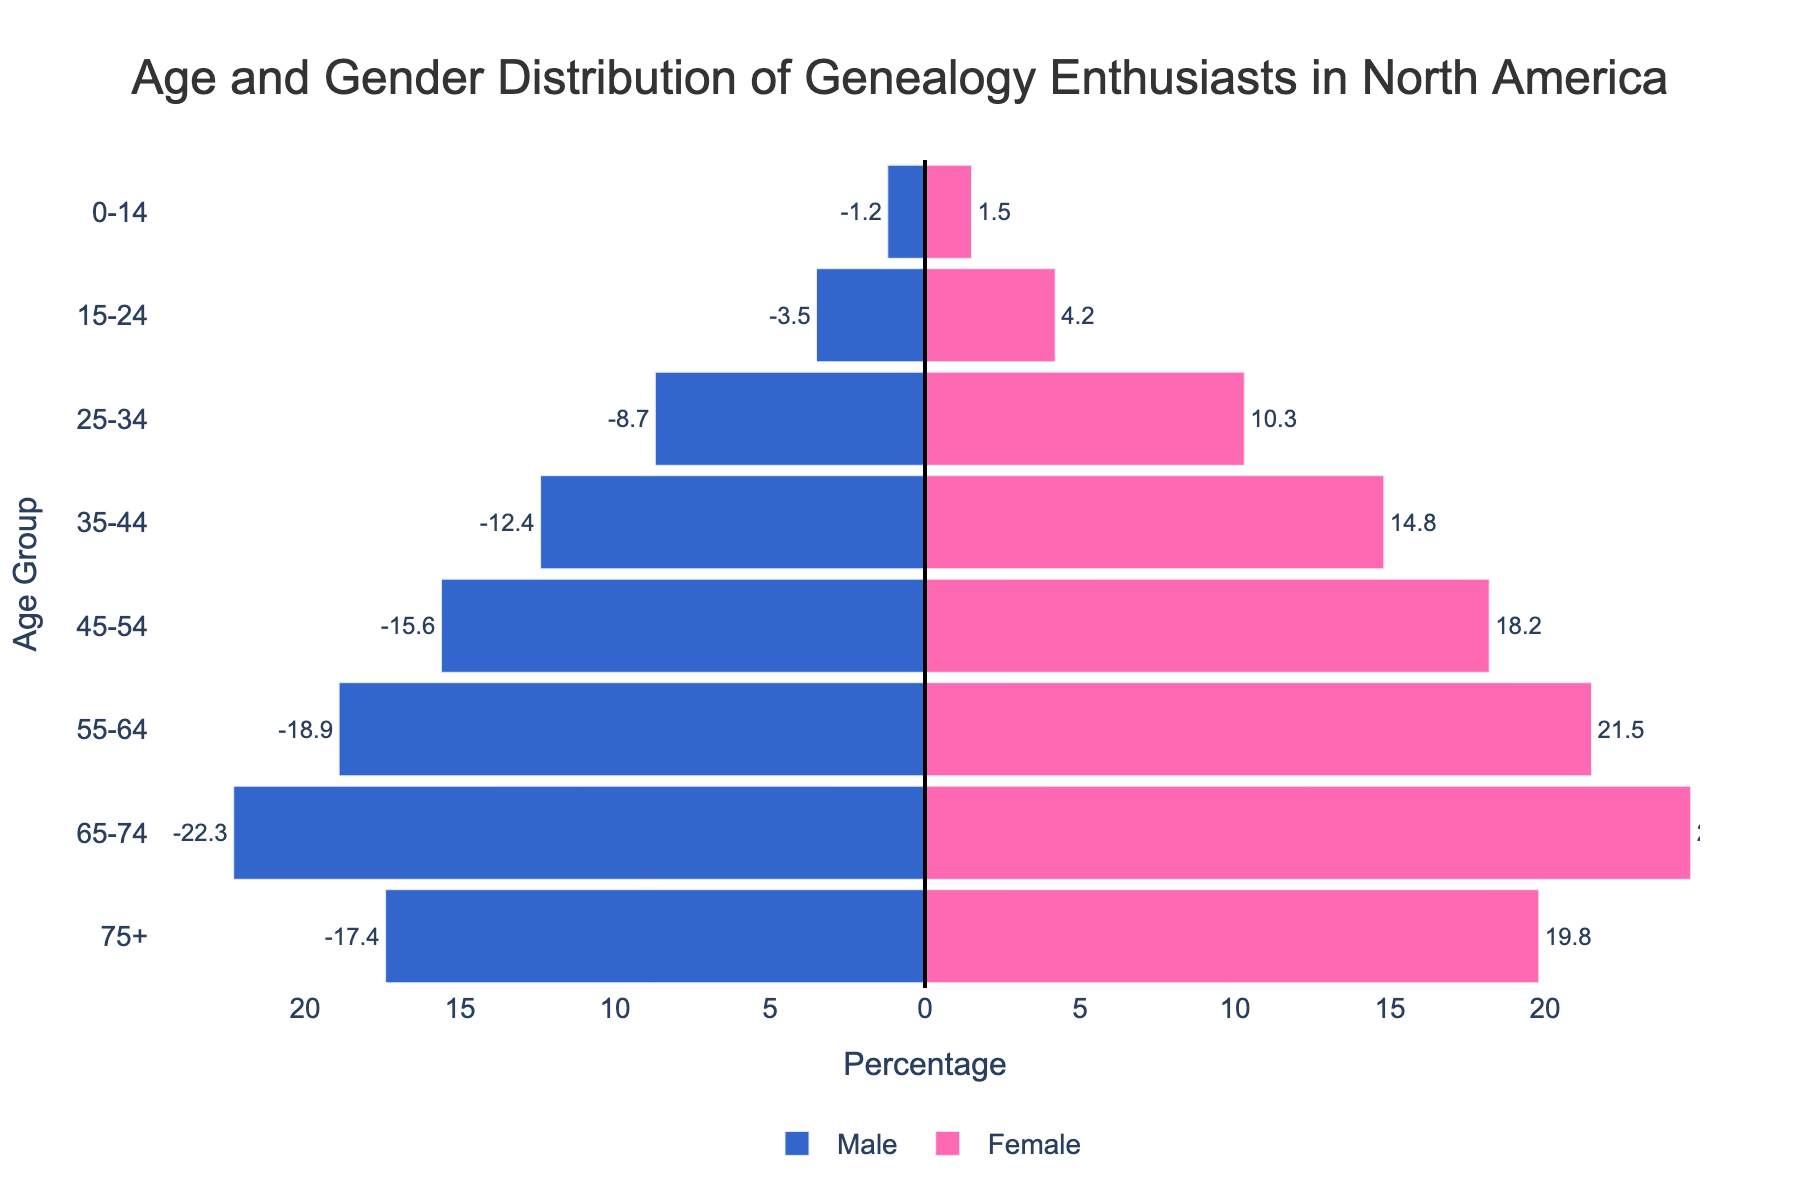What is the title of the plot? The title is usually displayed at the top of the plot and provides a summary of what is being depicted. Here the title "Age and Gender Distribution of Genealogy Enthusiasts in North America" indicates the subject of the plot.
Answer: Age and Gender Distribution of Genealogy Enthusiasts in North America What is the percentage of female genealogy enthusiasts in the 65-74 age group? Locate the 65-74 age group on the y-axis and check the length of the bar for females. The length indicates the percentage, which is shown to be 24.7%.
Answer: 24.7% Which age group has the highest percentage of male genealogy enthusiasts? By observing the lengths of the bars representing males, the 65-74 age group has the longest bar, thus indicating the highest percentage of 22.3%.
Answer: 65-74 What is the difference in percentage between male and female enthusiasts in the 35-44 age group? Locate the 35-44 age group and note the percentages for males (12.4%) and females (14.8%). The difference is calculated as 14.8% - 12.4% = 2.4%.
Answer: 2.4% How do the percentages of genealogy enthusiasts aged 0-14 compare between males and females? Locate the 0-14 age group and observe the bars for males (1.2%) and females (1.5%). Females have a slightly higher percentage than males.
Answer: Females have a higher percentage In which age groups are there more female enthusiasts compared to male enthusiasts? We need to identify the age groups by comparing the lengths of corresponding male and female bars. Females have higher percentages in all age groups: 0-14, 15-24, 25-34, 35-44, 45-54, 55-64, 65-74, and 75+.
Answer: All age groups What is the overall trend in percentages of genealogy enthusiasts in North America as age increases? Observing the plot, as age increases, the percentage of both male and female enthusiasts also increases up to the 65-74 age group and then slightly decreases in the 75+ age group.
Answer: Increase until 65-74, then slight decrease What is the total percentage of genealogy enthusiasts aged 45-54 for both genders combined? Add the percentages for males (15.6%) and females (18.2%) in the 45-54 age group. Thus, the total is 15.6% + 18.2% = 33.8%.
Answer: 33.8% How many age groups show a percentage of male genealogy enthusiasts greater than 10%? Count the age groups where the male bars extend beyond the 10% mark. These groups are 25-34, 35-44, 45-54, 55-64, 65-74, and 75+, making a total of 6 age groups.
Answer: 6 Which gender has a more even distribution across age groups? By comparing the lengths of bars for both genders across all age groups, the female percentages show a more consistent rise, while male percentages vary more drastically.
Answer: Female 